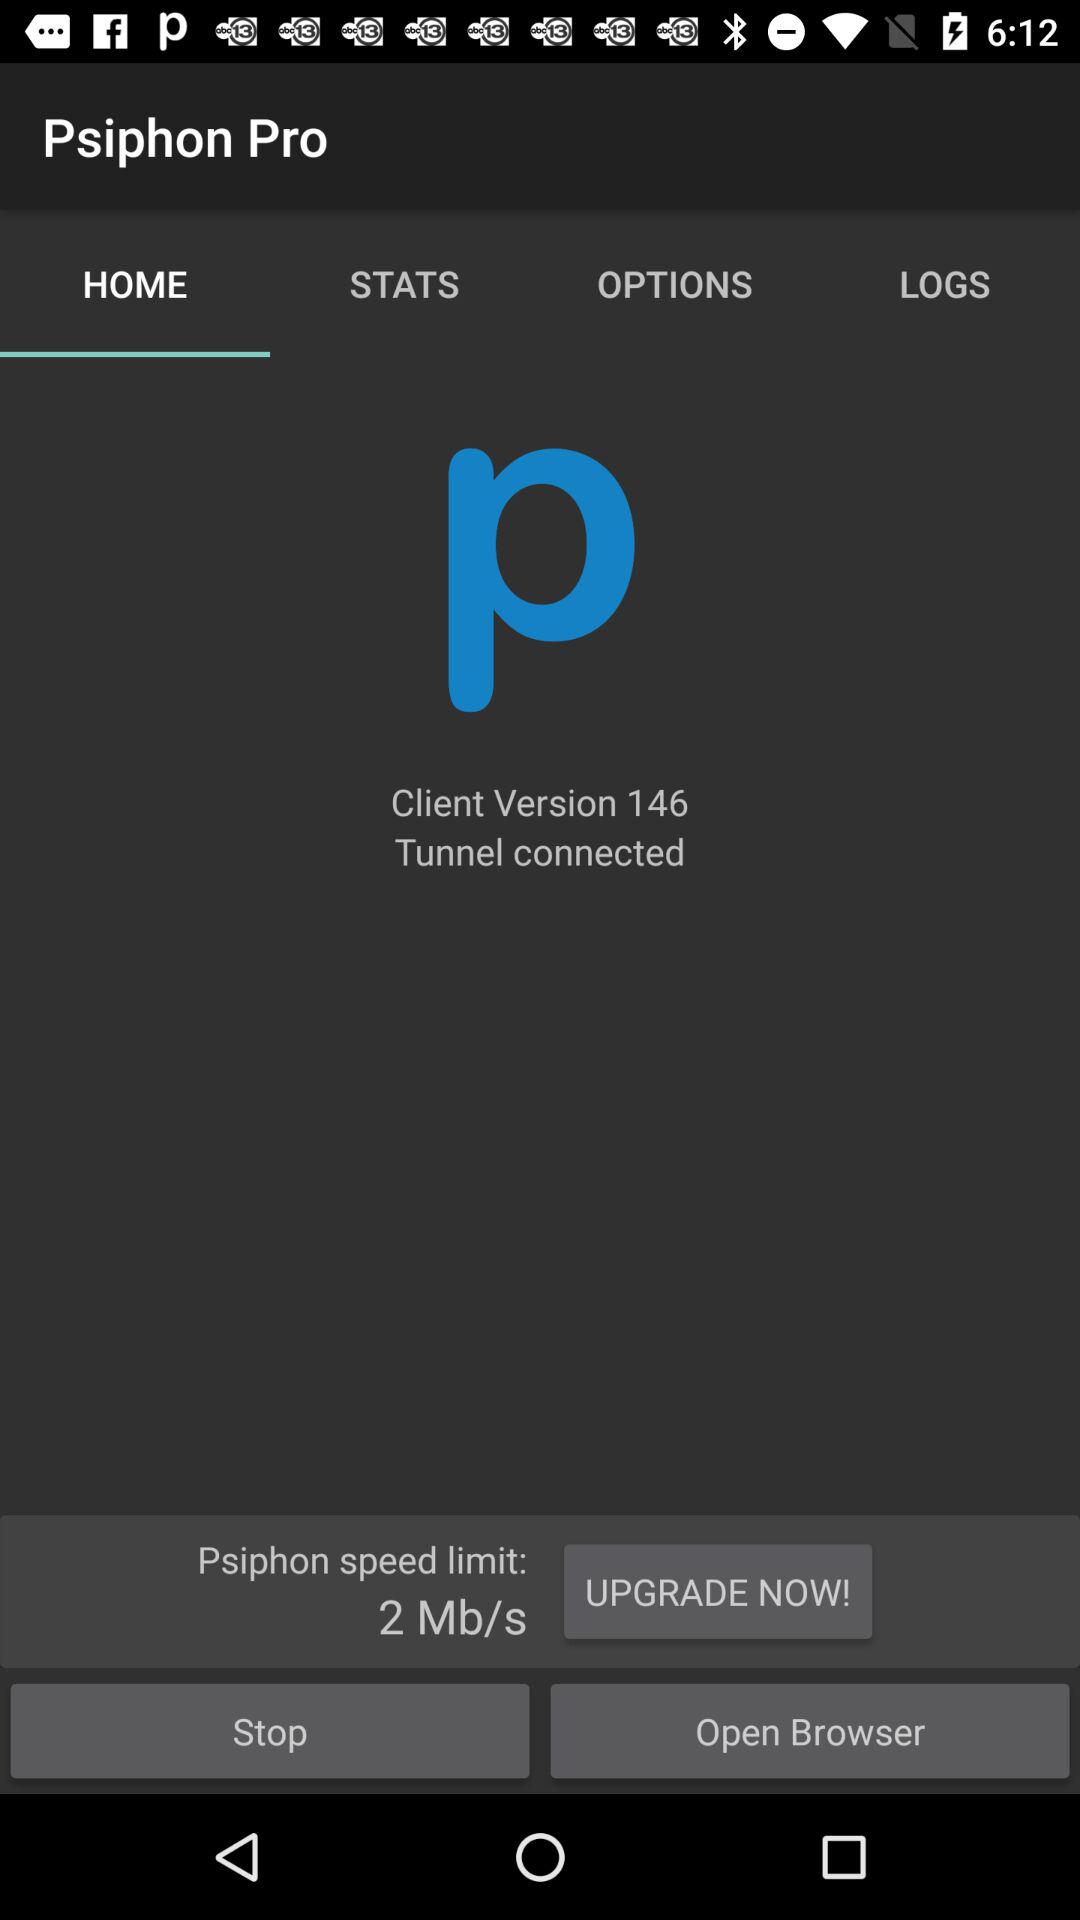What is the client version? The client version is 146. 